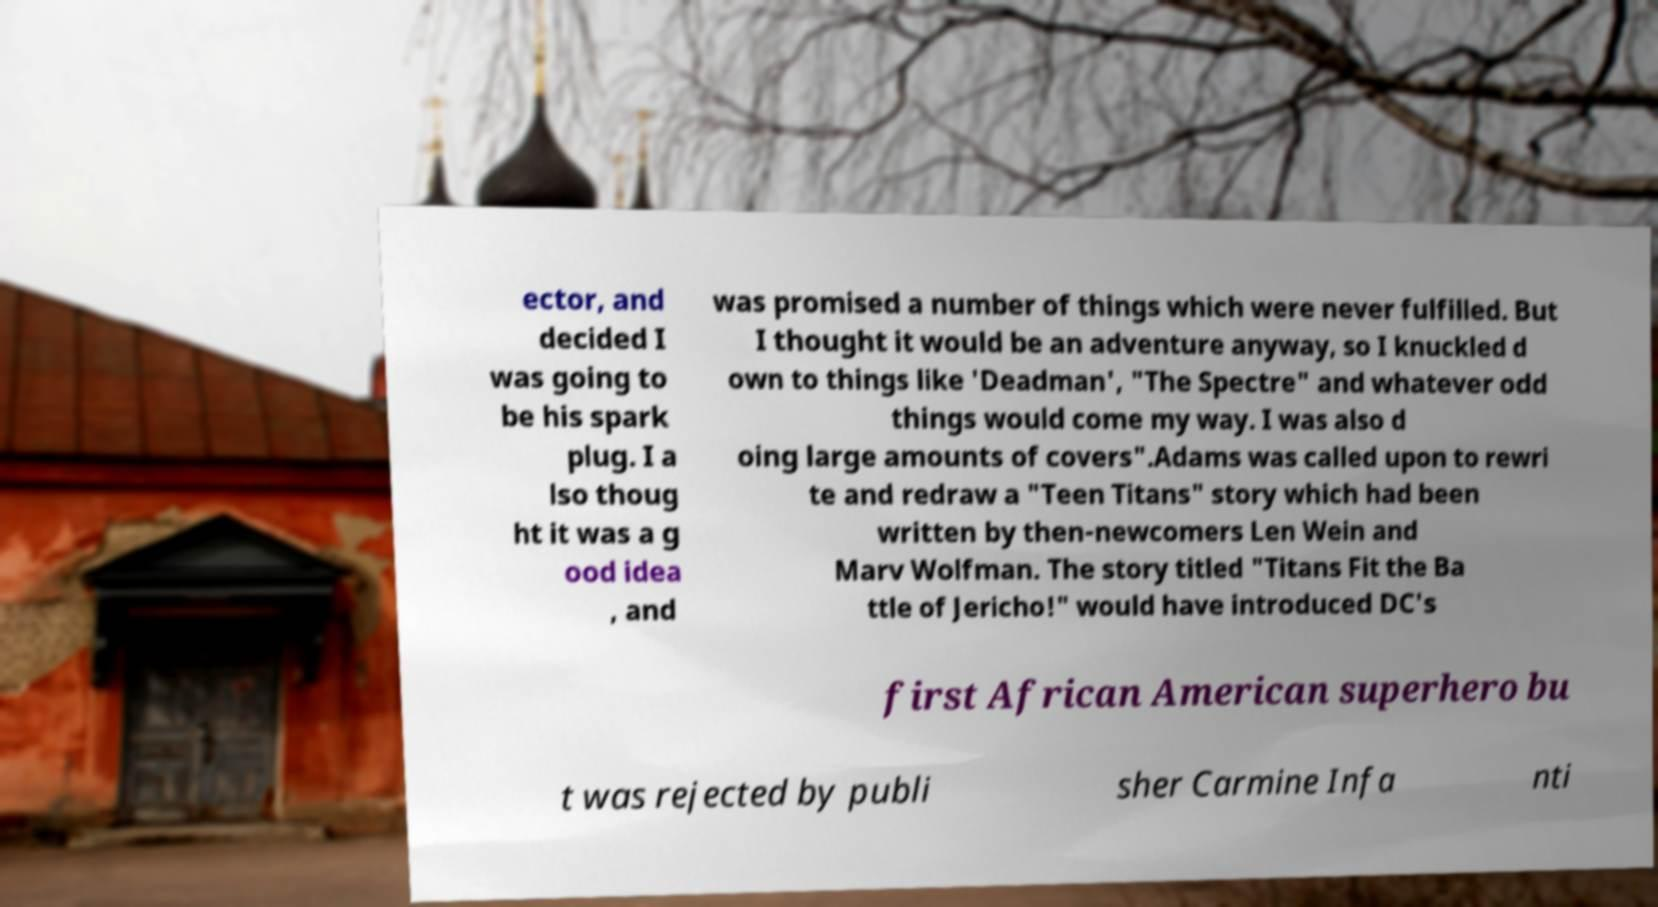What messages or text are displayed in this image? I need them in a readable, typed format. ector, and decided I was going to be his spark plug. I a lso thoug ht it was a g ood idea , and was promised a number of things which were never fulfilled. But I thought it would be an adventure anyway, so I knuckled d own to things like 'Deadman', "The Spectre" and whatever odd things would come my way. I was also d oing large amounts of covers".Adams was called upon to rewri te and redraw a "Teen Titans" story which had been written by then-newcomers Len Wein and Marv Wolfman. The story titled "Titans Fit the Ba ttle of Jericho!" would have introduced DC's first African American superhero bu t was rejected by publi sher Carmine Infa nti 